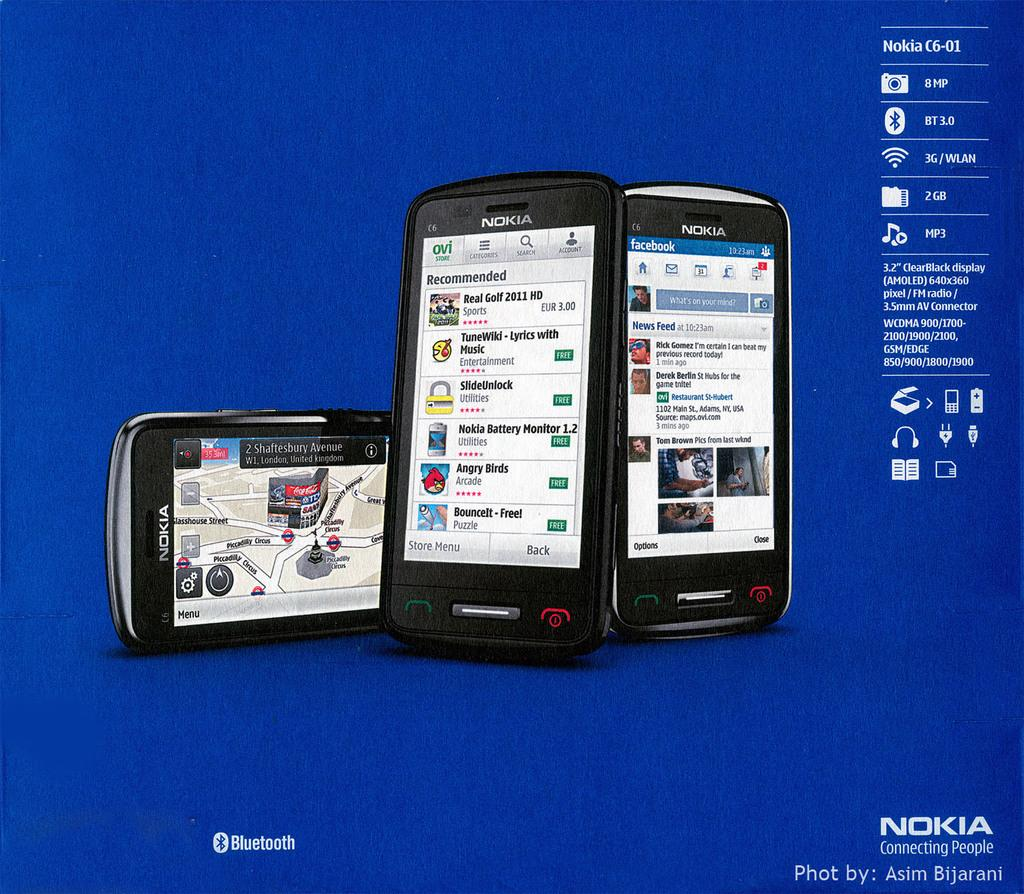<image>
Summarize the visual content of the image. Three Nokia phones sit next to each other in an ad that says Nokia is connecting people. 